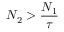<formula> <loc_0><loc_0><loc_500><loc_500>N _ { 2 } > \frac { N _ { 1 } } { \tau }</formula> 